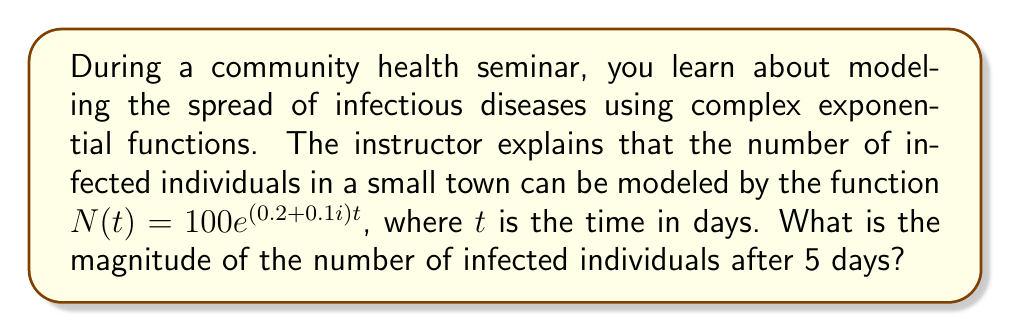Give your solution to this math problem. To solve this problem, we'll follow these steps:

1) The given function is $N(t) = 100e^{(0.2+0.1i)t}$

2) We need to find $|N(5)|$, the magnitude of $N(t)$ when $t=5$

3) First, let's calculate $N(5)$:
   $N(5) = 100e^{(0.2+0.1i)5}$
   $N(5) = 100e^{1+0.5i}$

4) To find the magnitude of a complex number in the form $re^{i\theta}$, we use $|re^{i\theta}| = r$

5) In our case, $r = 100e^1$

6) Calculate $e^1$:
   $e^1 \approx 2.71828$

7) Multiply by 100:
   $100e^1 \approx 100 \times 2.71828 \approx 271.828$

8) Round to the nearest whole number, as we're dealing with people:
   $|N(5)| \approx 272$
Answer: 272 